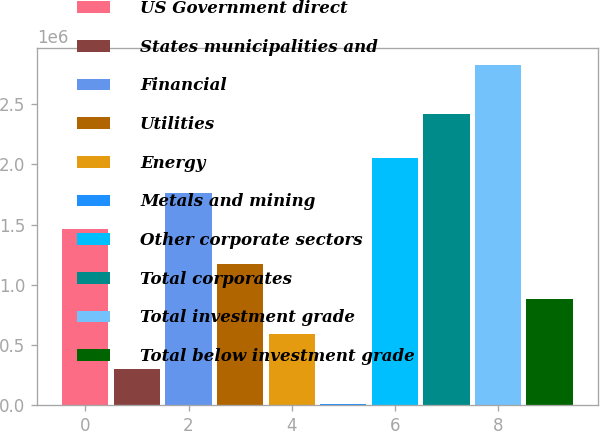Convert chart to OTSL. <chart><loc_0><loc_0><loc_500><loc_500><bar_chart><fcel>US Government direct<fcel>States municipalities and<fcel>Financial<fcel>Utilities<fcel>Energy<fcel>Metals and mining<fcel>Other corporate sectors<fcel>Total corporates<fcel>Total investment grade<fcel>Total below investment grade<nl><fcel>1.46719e+06<fcel>298186<fcel>1.75944e+06<fcel>1.17494e+06<fcel>590437<fcel>5936<fcel>2.05169e+06<fcel>2.42367e+06<fcel>2.82876e+06<fcel>882688<nl></chart> 